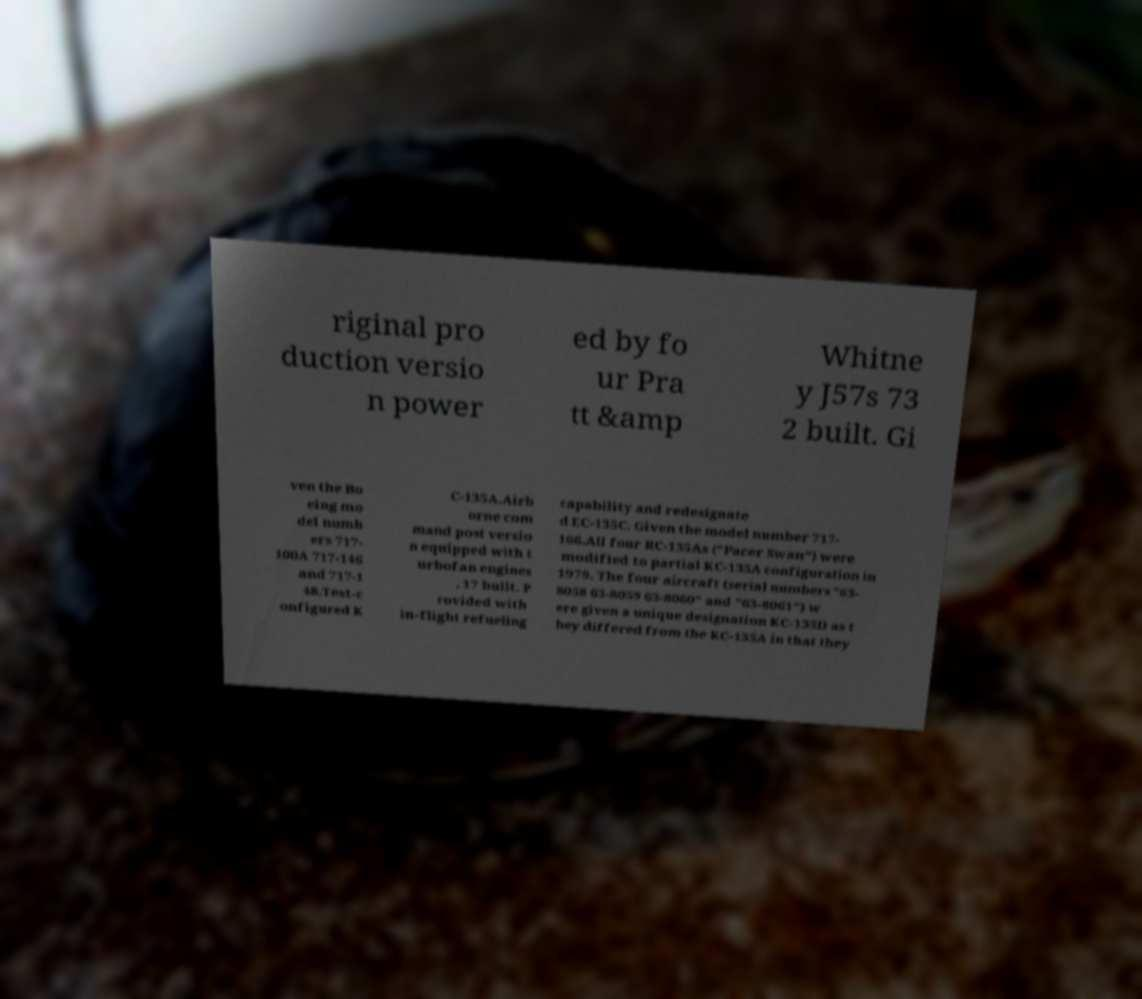Can you accurately transcribe the text from the provided image for me? riginal pro duction versio n power ed by fo ur Pra tt &amp Whitne y J57s 73 2 built. Gi ven the Bo eing mo del numb ers 717- 100A 717-146 and 717-1 48.Test-c onfigured K C-135A.Airb orne com mand post versio n equipped with t urbofan engines , 17 built. P rovided with in-flight refueling capability and redesignate d EC-135C. Given the model number 717- 166.All four RC-135As ("Pacer Swan") were modified to partial KC-135A configuration in 1979. The four aircraft (serial numbers "63- 8058 63-8059 63-8060" and "63-8061") w ere given a unique designation KC-135D as t hey differed from the KC-135A in that they 